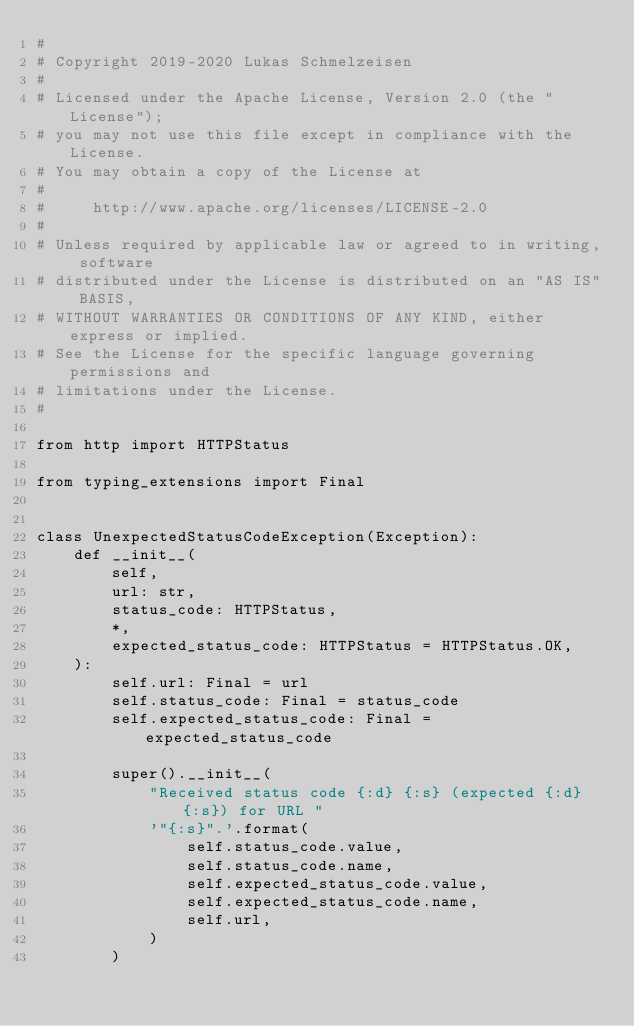<code> <loc_0><loc_0><loc_500><loc_500><_Python_>#
# Copyright 2019-2020 Lukas Schmelzeisen
#
# Licensed under the Apache License, Version 2.0 (the "License");
# you may not use this file except in compliance with the License.
# You may obtain a copy of the License at
#
#     http://www.apache.org/licenses/LICENSE-2.0
#
# Unless required by applicable law or agreed to in writing, software
# distributed under the License is distributed on an "AS IS" BASIS,
# WITHOUT WARRANTIES OR CONDITIONS OF ANY KIND, either express or implied.
# See the License for the specific language governing permissions and
# limitations under the License.
#

from http import HTTPStatus

from typing_extensions import Final


class UnexpectedStatusCodeException(Exception):
    def __init__(
        self,
        url: str,
        status_code: HTTPStatus,
        *,
        expected_status_code: HTTPStatus = HTTPStatus.OK,
    ):
        self.url: Final = url
        self.status_code: Final = status_code
        self.expected_status_code: Final = expected_status_code

        super().__init__(
            "Received status code {:d} {:s} (expected {:d} {:s}) for URL "
            '"{:s}".'.format(
                self.status_code.value,
                self.status_code.name,
                self.expected_status_code.value,
                self.expected_status_code.name,
                self.url,
            )
        )
</code> 